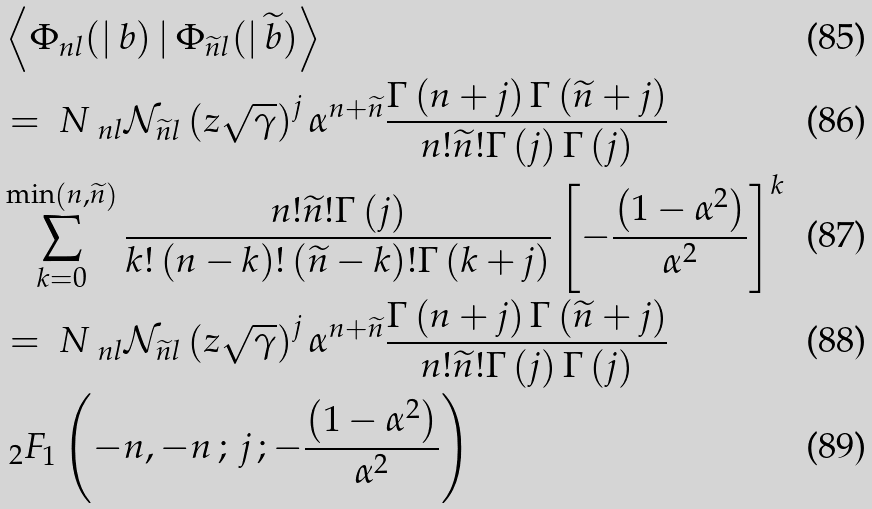Convert formula to latex. <formula><loc_0><loc_0><loc_500><loc_500>& \left \langle \Phi _ { n l } ( | \, b ) \, | \, \Phi _ { \widetilde { n } l } ( | \, \widetilde { b } ) \right \rangle \\ & = \emph { N } _ { n l } \mathcal { N } _ { \widetilde { n } l } \left ( z \sqrt { \gamma } \right ) ^ { j } \alpha ^ { n + \widetilde { n } } \frac { \Gamma \left ( n + j \right ) \Gamma \left ( \widetilde { n } + j \right ) } { n ! \widetilde { n } ! \Gamma \left ( j \right ) \Gamma \left ( j \right ) } \\ & \sum _ { k = 0 } ^ { \min \left ( n , \widetilde { n } \right ) } \frac { n ! \widetilde { n } ! \Gamma \left ( j \right ) } { k ! \left ( n - k \right ) ! \left ( \widetilde { n } - k \right ) ! \Gamma \left ( k + j \right ) } \left [ - \frac { \left ( 1 - \alpha ^ { 2 } \right ) } { \alpha ^ { 2 } } \right ] ^ { k } \\ & = \emph { N } _ { n l } \mathcal { N } _ { \widetilde { n } l } \left ( z \sqrt { \gamma } \right ) ^ { j } \alpha ^ { n + \widetilde { n } } \frac { \Gamma \left ( n + j \right ) \Gamma \left ( \widetilde { n } + j \right ) } { n ! \widetilde { n } ! \Gamma \left ( j \right ) \Gamma \left ( j \right ) } \\ & \ _ { 2 } F _ { 1 } \left ( - n , - n \, ; \, j \, ; - \frac { \left ( 1 - \alpha ^ { 2 } \right ) } { \alpha ^ { 2 } } \right )</formula> 